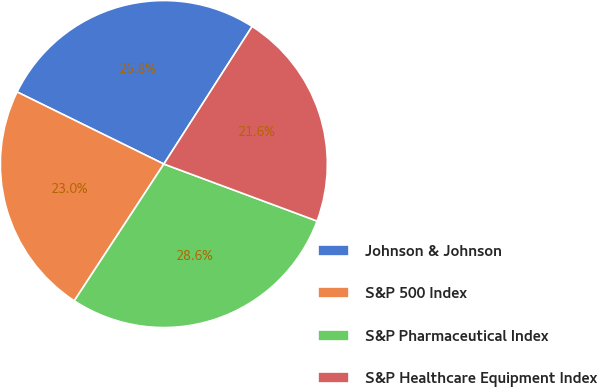Convert chart to OTSL. <chart><loc_0><loc_0><loc_500><loc_500><pie_chart><fcel>Johnson & Johnson<fcel>S&P 500 Index<fcel>S&P Pharmaceutical Index<fcel>S&P Healthcare Equipment Index<nl><fcel>26.81%<fcel>23.04%<fcel>28.56%<fcel>21.59%<nl></chart> 